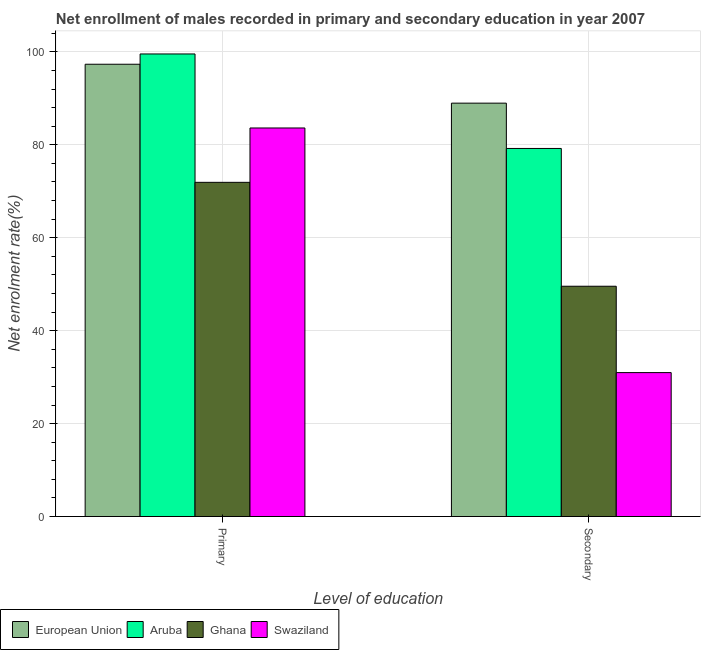How many different coloured bars are there?
Offer a very short reply. 4. How many groups of bars are there?
Your answer should be very brief. 2. Are the number of bars per tick equal to the number of legend labels?
Offer a very short reply. Yes. Are the number of bars on each tick of the X-axis equal?
Offer a very short reply. Yes. How many bars are there on the 2nd tick from the right?
Keep it short and to the point. 4. What is the label of the 2nd group of bars from the left?
Give a very brief answer. Secondary. What is the enrollment rate in secondary education in Ghana?
Offer a very short reply. 49.56. Across all countries, what is the maximum enrollment rate in primary education?
Your response must be concise. 99.55. Across all countries, what is the minimum enrollment rate in primary education?
Provide a short and direct response. 71.92. In which country was the enrollment rate in secondary education minimum?
Provide a short and direct response. Swaziland. What is the total enrollment rate in primary education in the graph?
Your answer should be very brief. 352.41. What is the difference between the enrollment rate in primary education in Aruba and that in Swaziland?
Give a very brief answer. 15.93. What is the difference between the enrollment rate in secondary education in Swaziland and the enrollment rate in primary education in Ghana?
Offer a very short reply. -40.95. What is the average enrollment rate in secondary education per country?
Give a very brief answer. 62.17. What is the difference between the enrollment rate in secondary education and enrollment rate in primary education in Ghana?
Offer a terse response. -22.36. What is the ratio of the enrollment rate in primary education in Ghana to that in Aruba?
Offer a very short reply. 0.72. In how many countries, is the enrollment rate in primary education greater than the average enrollment rate in primary education taken over all countries?
Offer a very short reply. 2. What does the 2nd bar from the left in Primary represents?
Keep it short and to the point. Aruba. How many countries are there in the graph?
Your response must be concise. 4. What is the difference between two consecutive major ticks on the Y-axis?
Give a very brief answer. 20. Does the graph contain any zero values?
Ensure brevity in your answer.  No. Does the graph contain grids?
Offer a terse response. Yes. Where does the legend appear in the graph?
Offer a terse response. Bottom left. What is the title of the graph?
Make the answer very short. Net enrollment of males recorded in primary and secondary education in year 2007. Does "Least developed countries" appear as one of the legend labels in the graph?
Your answer should be compact. No. What is the label or title of the X-axis?
Give a very brief answer. Level of education. What is the label or title of the Y-axis?
Offer a terse response. Net enrolment rate(%). What is the Net enrolment rate(%) in European Union in Primary?
Provide a short and direct response. 97.33. What is the Net enrolment rate(%) of Aruba in Primary?
Give a very brief answer. 99.55. What is the Net enrolment rate(%) in Ghana in Primary?
Offer a terse response. 71.92. What is the Net enrolment rate(%) of Swaziland in Primary?
Your response must be concise. 83.62. What is the Net enrolment rate(%) in European Union in Secondary?
Provide a succinct answer. 88.96. What is the Net enrolment rate(%) in Aruba in Secondary?
Provide a succinct answer. 79.21. What is the Net enrolment rate(%) in Ghana in Secondary?
Offer a terse response. 49.56. What is the Net enrolment rate(%) of Swaziland in Secondary?
Give a very brief answer. 30.97. Across all Level of education, what is the maximum Net enrolment rate(%) of European Union?
Your response must be concise. 97.33. Across all Level of education, what is the maximum Net enrolment rate(%) in Aruba?
Provide a short and direct response. 99.55. Across all Level of education, what is the maximum Net enrolment rate(%) of Ghana?
Your answer should be very brief. 71.92. Across all Level of education, what is the maximum Net enrolment rate(%) of Swaziland?
Ensure brevity in your answer.  83.62. Across all Level of education, what is the minimum Net enrolment rate(%) in European Union?
Give a very brief answer. 88.96. Across all Level of education, what is the minimum Net enrolment rate(%) of Aruba?
Offer a terse response. 79.21. Across all Level of education, what is the minimum Net enrolment rate(%) in Ghana?
Provide a short and direct response. 49.56. Across all Level of education, what is the minimum Net enrolment rate(%) of Swaziland?
Make the answer very short. 30.97. What is the total Net enrolment rate(%) in European Union in the graph?
Ensure brevity in your answer.  186.29. What is the total Net enrolment rate(%) in Aruba in the graph?
Keep it short and to the point. 178.76. What is the total Net enrolment rate(%) in Ghana in the graph?
Provide a succinct answer. 121.47. What is the total Net enrolment rate(%) of Swaziland in the graph?
Your answer should be very brief. 114.59. What is the difference between the Net enrolment rate(%) in European Union in Primary and that in Secondary?
Give a very brief answer. 8.37. What is the difference between the Net enrolment rate(%) of Aruba in Primary and that in Secondary?
Your answer should be compact. 20.34. What is the difference between the Net enrolment rate(%) of Ghana in Primary and that in Secondary?
Keep it short and to the point. 22.36. What is the difference between the Net enrolment rate(%) of Swaziland in Primary and that in Secondary?
Give a very brief answer. 52.64. What is the difference between the Net enrolment rate(%) in European Union in Primary and the Net enrolment rate(%) in Aruba in Secondary?
Make the answer very short. 18.12. What is the difference between the Net enrolment rate(%) of European Union in Primary and the Net enrolment rate(%) of Ghana in Secondary?
Provide a short and direct response. 47.77. What is the difference between the Net enrolment rate(%) of European Union in Primary and the Net enrolment rate(%) of Swaziland in Secondary?
Your answer should be compact. 66.36. What is the difference between the Net enrolment rate(%) in Aruba in Primary and the Net enrolment rate(%) in Ghana in Secondary?
Offer a very short reply. 49.99. What is the difference between the Net enrolment rate(%) of Aruba in Primary and the Net enrolment rate(%) of Swaziland in Secondary?
Your answer should be very brief. 68.57. What is the difference between the Net enrolment rate(%) in Ghana in Primary and the Net enrolment rate(%) in Swaziland in Secondary?
Give a very brief answer. 40.95. What is the average Net enrolment rate(%) in European Union per Level of education?
Make the answer very short. 93.14. What is the average Net enrolment rate(%) of Aruba per Level of education?
Provide a succinct answer. 89.38. What is the average Net enrolment rate(%) in Ghana per Level of education?
Your answer should be very brief. 60.74. What is the average Net enrolment rate(%) of Swaziland per Level of education?
Your answer should be very brief. 57.29. What is the difference between the Net enrolment rate(%) of European Union and Net enrolment rate(%) of Aruba in Primary?
Your response must be concise. -2.22. What is the difference between the Net enrolment rate(%) of European Union and Net enrolment rate(%) of Ghana in Primary?
Your response must be concise. 25.41. What is the difference between the Net enrolment rate(%) in European Union and Net enrolment rate(%) in Swaziland in Primary?
Make the answer very short. 13.71. What is the difference between the Net enrolment rate(%) in Aruba and Net enrolment rate(%) in Ghana in Primary?
Offer a terse response. 27.63. What is the difference between the Net enrolment rate(%) in Aruba and Net enrolment rate(%) in Swaziland in Primary?
Give a very brief answer. 15.93. What is the difference between the Net enrolment rate(%) in Ghana and Net enrolment rate(%) in Swaziland in Primary?
Keep it short and to the point. -11.7. What is the difference between the Net enrolment rate(%) in European Union and Net enrolment rate(%) in Aruba in Secondary?
Your answer should be very brief. 9.75. What is the difference between the Net enrolment rate(%) in European Union and Net enrolment rate(%) in Ghana in Secondary?
Make the answer very short. 39.4. What is the difference between the Net enrolment rate(%) in European Union and Net enrolment rate(%) in Swaziland in Secondary?
Your answer should be very brief. 57.99. What is the difference between the Net enrolment rate(%) in Aruba and Net enrolment rate(%) in Ghana in Secondary?
Ensure brevity in your answer.  29.65. What is the difference between the Net enrolment rate(%) of Aruba and Net enrolment rate(%) of Swaziland in Secondary?
Ensure brevity in your answer.  48.24. What is the difference between the Net enrolment rate(%) of Ghana and Net enrolment rate(%) of Swaziland in Secondary?
Offer a very short reply. 18.59. What is the ratio of the Net enrolment rate(%) of European Union in Primary to that in Secondary?
Offer a very short reply. 1.09. What is the ratio of the Net enrolment rate(%) in Aruba in Primary to that in Secondary?
Make the answer very short. 1.26. What is the ratio of the Net enrolment rate(%) of Ghana in Primary to that in Secondary?
Your response must be concise. 1.45. What is the ratio of the Net enrolment rate(%) of Swaziland in Primary to that in Secondary?
Keep it short and to the point. 2.7. What is the difference between the highest and the second highest Net enrolment rate(%) in European Union?
Provide a short and direct response. 8.37. What is the difference between the highest and the second highest Net enrolment rate(%) in Aruba?
Offer a very short reply. 20.34. What is the difference between the highest and the second highest Net enrolment rate(%) of Ghana?
Ensure brevity in your answer.  22.36. What is the difference between the highest and the second highest Net enrolment rate(%) in Swaziland?
Ensure brevity in your answer.  52.64. What is the difference between the highest and the lowest Net enrolment rate(%) in European Union?
Give a very brief answer. 8.37. What is the difference between the highest and the lowest Net enrolment rate(%) in Aruba?
Provide a short and direct response. 20.34. What is the difference between the highest and the lowest Net enrolment rate(%) in Ghana?
Keep it short and to the point. 22.36. What is the difference between the highest and the lowest Net enrolment rate(%) of Swaziland?
Your answer should be very brief. 52.64. 